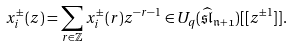<formula> <loc_0><loc_0><loc_500><loc_500>x _ { i } ^ { \pm } ( z ) = \sum _ { r \in \mathbb { Z } } x _ { i } ^ { \pm } ( r ) z ^ { - r - 1 } \in U _ { q } ( \mathfrak { \widehat { \mathfrak { s l } } _ { n + 1 } } ) [ [ z ^ { \pm 1 } ] ] .</formula> 